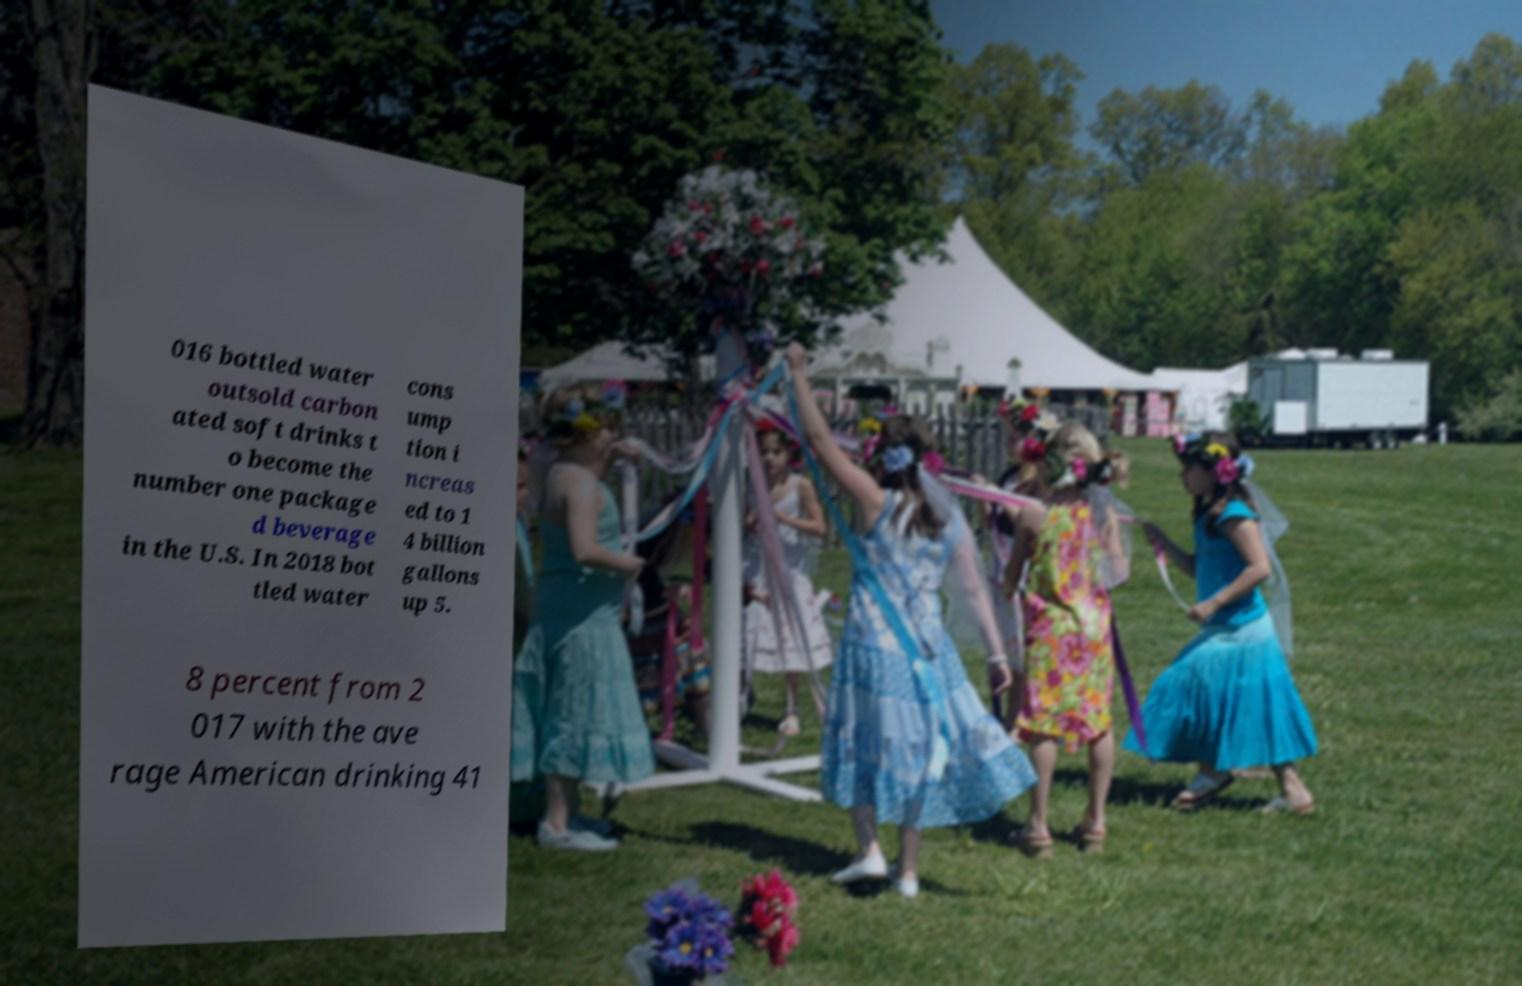For documentation purposes, I need the text within this image transcribed. Could you provide that? 016 bottled water outsold carbon ated soft drinks t o become the number one package d beverage in the U.S. In 2018 bot tled water cons ump tion i ncreas ed to 1 4 billion gallons up 5. 8 percent from 2 017 with the ave rage American drinking 41 